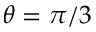<formula> <loc_0><loc_0><loc_500><loc_500>\theta = \pi / 3</formula> 